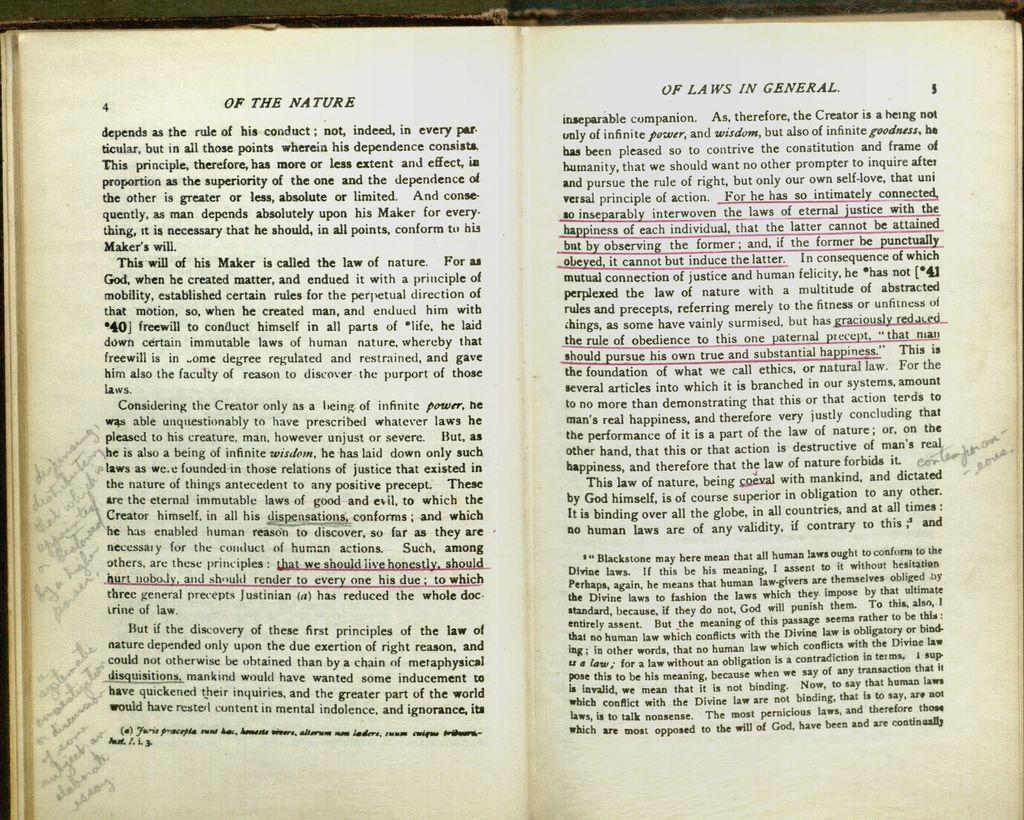Provide a one-sentence caption for the provided image. A book open to pages 4 and 5 "Of the Nature Of Laws in General". 